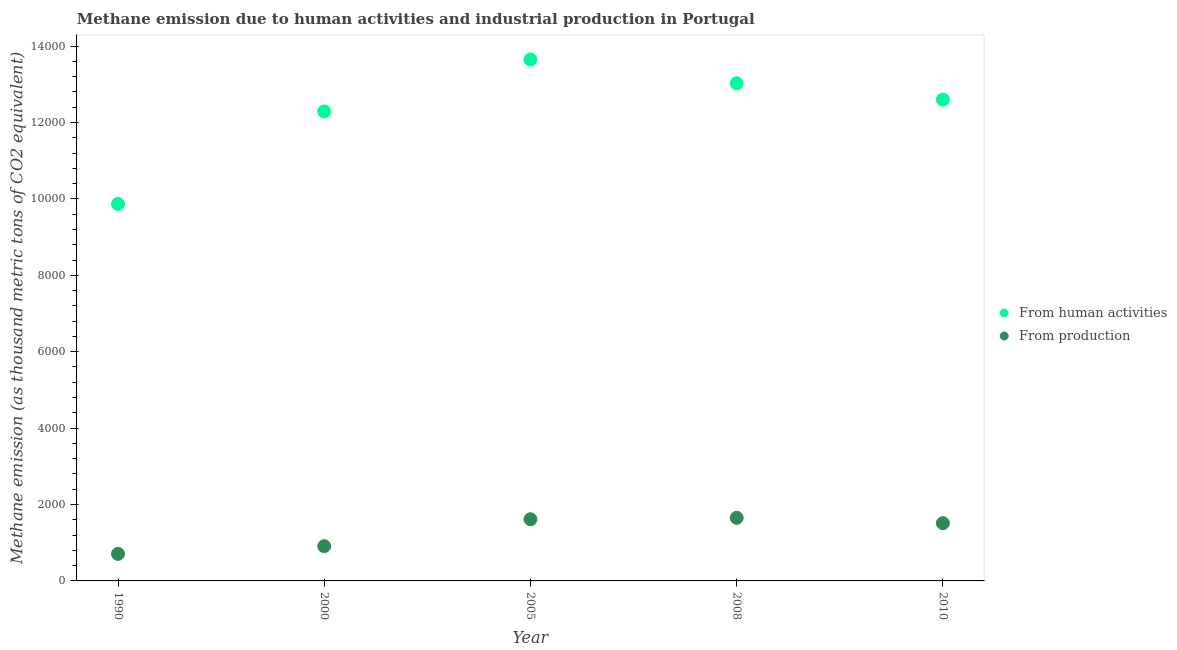Is the number of dotlines equal to the number of legend labels?
Your response must be concise. Yes. What is the amount of emissions from human activities in 2010?
Provide a succinct answer. 1.26e+04. Across all years, what is the maximum amount of emissions generated from industries?
Keep it short and to the point. 1651.1. Across all years, what is the minimum amount of emissions from human activities?
Your response must be concise. 9868.6. In which year was the amount of emissions generated from industries minimum?
Give a very brief answer. 1990. What is the total amount of emissions from human activities in the graph?
Provide a succinct answer. 6.14e+04. What is the difference between the amount of emissions generated from industries in 1990 and that in 2010?
Make the answer very short. -802.8. What is the difference between the amount of emissions from human activities in 2010 and the amount of emissions generated from industries in 2005?
Offer a very short reply. 1.10e+04. What is the average amount of emissions generated from industries per year?
Provide a succinct answer. 1279.18. In the year 1990, what is the difference between the amount of emissions from human activities and amount of emissions generated from industries?
Offer a very short reply. 9159.9. What is the ratio of the amount of emissions generated from industries in 2000 to that in 2010?
Provide a short and direct response. 0.6. Is the amount of emissions from human activities in 2008 less than that in 2010?
Give a very brief answer. No. Is the difference between the amount of emissions from human activities in 2000 and 2005 greater than the difference between the amount of emissions generated from industries in 2000 and 2005?
Keep it short and to the point. No. What is the difference between the highest and the second highest amount of emissions from human activities?
Ensure brevity in your answer.  620. What is the difference between the highest and the lowest amount of emissions from human activities?
Your answer should be compact. 3778.3. In how many years, is the amount of emissions from human activities greater than the average amount of emissions from human activities taken over all years?
Make the answer very short. 4. What is the difference between two consecutive major ticks on the Y-axis?
Give a very brief answer. 2000. Are the values on the major ticks of Y-axis written in scientific E-notation?
Give a very brief answer. No. Does the graph contain any zero values?
Your response must be concise. No. Does the graph contain grids?
Offer a very short reply. No. Where does the legend appear in the graph?
Your answer should be very brief. Center right. How many legend labels are there?
Your answer should be very brief. 2. What is the title of the graph?
Provide a short and direct response. Methane emission due to human activities and industrial production in Portugal. Does "National Tourists" appear as one of the legend labels in the graph?
Offer a very short reply. No. What is the label or title of the Y-axis?
Your answer should be very brief. Methane emission (as thousand metric tons of CO2 equivalent). What is the Methane emission (as thousand metric tons of CO2 equivalent) of From human activities in 1990?
Offer a terse response. 9868.6. What is the Methane emission (as thousand metric tons of CO2 equivalent) in From production in 1990?
Your answer should be very brief. 708.7. What is the Methane emission (as thousand metric tons of CO2 equivalent) of From human activities in 2000?
Your response must be concise. 1.23e+04. What is the Methane emission (as thousand metric tons of CO2 equivalent) in From production in 2000?
Give a very brief answer. 909.6. What is the Methane emission (as thousand metric tons of CO2 equivalent) in From human activities in 2005?
Provide a succinct answer. 1.36e+04. What is the Methane emission (as thousand metric tons of CO2 equivalent) in From production in 2005?
Offer a very short reply. 1615. What is the Methane emission (as thousand metric tons of CO2 equivalent) of From human activities in 2008?
Keep it short and to the point. 1.30e+04. What is the Methane emission (as thousand metric tons of CO2 equivalent) in From production in 2008?
Keep it short and to the point. 1651.1. What is the Methane emission (as thousand metric tons of CO2 equivalent) of From human activities in 2010?
Make the answer very short. 1.26e+04. What is the Methane emission (as thousand metric tons of CO2 equivalent) in From production in 2010?
Provide a short and direct response. 1511.5. Across all years, what is the maximum Methane emission (as thousand metric tons of CO2 equivalent) in From human activities?
Your response must be concise. 1.36e+04. Across all years, what is the maximum Methane emission (as thousand metric tons of CO2 equivalent) of From production?
Provide a succinct answer. 1651.1. Across all years, what is the minimum Methane emission (as thousand metric tons of CO2 equivalent) in From human activities?
Make the answer very short. 9868.6. Across all years, what is the minimum Methane emission (as thousand metric tons of CO2 equivalent) of From production?
Your answer should be compact. 708.7. What is the total Methane emission (as thousand metric tons of CO2 equivalent) in From human activities in the graph?
Provide a succinct answer. 6.14e+04. What is the total Methane emission (as thousand metric tons of CO2 equivalent) of From production in the graph?
Offer a terse response. 6395.9. What is the difference between the Methane emission (as thousand metric tons of CO2 equivalent) of From human activities in 1990 and that in 2000?
Provide a short and direct response. -2420.5. What is the difference between the Methane emission (as thousand metric tons of CO2 equivalent) of From production in 1990 and that in 2000?
Your answer should be very brief. -200.9. What is the difference between the Methane emission (as thousand metric tons of CO2 equivalent) in From human activities in 1990 and that in 2005?
Your answer should be very brief. -3778.3. What is the difference between the Methane emission (as thousand metric tons of CO2 equivalent) in From production in 1990 and that in 2005?
Your answer should be very brief. -906.3. What is the difference between the Methane emission (as thousand metric tons of CO2 equivalent) in From human activities in 1990 and that in 2008?
Your response must be concise. -3158.3. What is the difference between the Methane emission (as thousand metric tons of CO2 equivalent) in From production in 1990 and that in 2008?
Your answer should be very brief. -942.4. What is the difference between the Methane emission (as thousand metric tons of CO2 equivalent) of From human activities in 1990 and that in 2010?
Your response must be concise. -2731.9. What is the difference between the Methane emission (as thousand metric tons of CO2 equivalent) of From production in 1990 and that in 2010?
Your response must be concise. -802.8. What is the difference between the Methane emission (as thousand metric tons of CO2 equivalent) in From human activities in 2000 and that in 2005?
Offer a very short reply. -1357.8. What is the difference between the Methane emission (as thousand metric tons of CO2 equivalent) in From production in 2000 and that in 2005?
Keep it short and to the point. -705.4. What is the difference between the Methane emission (as thousand metric tons of CO2 equivalent) of From human activities in 2000 and that in 2008?
Keep it short and to the point. -737.8. What is the difference between the Methane emission (as thousand metric tons of CO2 equivalent) of From production in 2000 and that in 2008?
Make the answer very short. -741.5. What is the difference between the Methane emission (as thousand metric tons of CO2 equivalent) in From human activities in 2000 and that in 2010?
Ensure brevity in your answer.  -311.4. What is the difference between the Methane emission (as thousand metric tons of CO2 equivalent) in From production in 2000 and that in 2010?
Offer a very short reply. -601.9. What is the difference between the Methane emission (as thousand metric tons of CO2 equivalent) of From human activities in 2005 and that in 2008?
Your answer should be compact. 620. What is the difference between the Methane emission (as thousand metric tons of CO2 equivalent) in From production in 2005 and that in 2008?
Ensure brevity in your answer.  -36.1. What is the difference between the Methane emission (as thousand metric tons of CO2 equivalent) of From human activities in 2005 and that in 2010?
Make the answer very short. 1046.4. What is the difference between the Methane emission (as thousand metric tons of CO2 equivalent) in From production in 2005 and that in 2010?
Ensure brevity in your answer.  103.5. What is the difference between the Methane emission (as thousand metric tons of CO2 equivalent) in From human activities in 2008 and that in 2010?
Your answer should be very brief. 426.4. What is the difference between the Methane emission (as thousand metric tons of CO2 equivalent) of From production in 2008 and that in 2010?
Ensure brevity in your answer.  139.6. What is the difference between the Methane emission (as thousand metric tons of CO2 equivalent) in From human activities in 1990 and the Methane emission (as thousand metric tons of CO2 equivalent) in From production in 2000?
Ensure brevity in your answer.  8959. What is the difference between the Methane emission (as thousand metric tons of CO2 equivalent) in From human activities in 1990 and the Methane emission (as thousand metric tons of CO2 equivalent) in From production in 2005?
Your response must be concise. 8253.6. What is the difference between the Methane emission (as thousand metric tons of CO2 equivalent) of From human activities in 1990 and the Methane emission (as thousand metric tons of CO2 equivalent) of From production in 2008?
Give a very brief answer. 8217.5. What is the difference between the Methane emission (as thousand metric tons of CO2 equivalent) of From human activities in 1990 and the Methane emission (as thousand metric tons of CO2 equivalent) of From production in 2010?
Offer a very short reply. 8357.1. What is the difference between the Methane emission (as thousand metric tons of CO2 equivalent) of From human activities in 2000 and the Methane emission (as thousand metric tons of CO2 equivalent) of From production in 2005?
Make the answer very short. 1.07e+04. What is the difference between the Methane emission (as thousand metric tons of CO2 equivalent) of From human activities in 2000 and the Methane emission (as thousand metric tons of CO2 equivalent) of From production in 2008?
Give a very brief answer. 1.06e+04. What is the difference between the Methane emission (as thousand metric tons of CO2 equivalent) of From human activities in 2000 and the Methane emission (as thousand metric tons of CO2 equivalent) of From production in 2010?
Give a very brief answer. 1.08e+04. What is the difference between the Methane emission (as thousand metric tons of CO2 equivalent) in From human activities in 2005 and the Methane emission (as thousand metric tons of CO2 equivalent) in From production in 2008?
Make the answer very short. 1.20e+04. What is the difference between the Methane emission (as thousand metric tons of CO2 equivalent) in From human activities in 2005 and the Methane emission (as thousand metric tons of CO2 equivalent) in From production in 2010?
Your answer should be compact. 1.21e+04. What is the difference between the Methane emission (as thousand metric tons of CO2 equivalent) in From human activities in 2008 and the Methane emission (as thousand metric tons of CO2 equivalent) in From production in 2010?
Provide a succinct answer. 1.15e+04. What is the average Methane emission (as thousand metric tons of CO2 equivalent) of From human activities per year?
Provide a succinct answer. 1.23e+04. What is the average Methane emission (as thousand metric tons of CO2 equivalent) in From production per year?
Ensure brevity in your answer.  1279.18. In the year 1990, what is the difference between the Methane emission (as thousand metric tons of CO2 equivalent) in From human activities and Methane emission (as thousand metric tons of CO2 equivalent) in From production?
Your answer should be very brief. 9159.9. In the year 2000, what is the difference between the Methane emission (as thousand metric tons of CO2 equivalent) in From human activities and Methane emission (as thousand metric tons of CO2 equivalent) in From production?
Ensure brevity in your answer.  1.14e+04. In the year 2005, what is the difference between the Methane emission (as thousand metric tons of CO2 equivalent) in From human activities and Methane emission (as thousand metric tons of CO2 equivalent) in From production?
Provide a short and direct response. 1.20e+04. In the year 2008, what is the difference between the Methane emission (as thousand metric tons of CO2 equivalent) in From human activities and Methane emission (as thousand metric tons of CO2 equivalent) in From production?
Your answer should be compact. 1.14e+04. In the year 2010, what is the difference between the Methane emission (as thousand metric tons of CO2 equivalent) of From human activities and Methane emission (as thousand metric tons of CO2 equivalent) of From production?
Keep it short and to the point. 1.11e+04. What is the ratio of the Methane emission (as thousand metric tons of CO2 equivalent) of From human activities in 1990 to that in 2000?
Provide a short and direct response. 0.8. What is the ratio of the Methane emission (as thousand metric tons of CO2 equivalent) in From production in 1990 to that in 2000?
Offer a terse response. 0.78. What is the ratio of the Methane emission (as thousand metric tons of CO2 equivalent) in From human activities in 1990 to that in 2005?
Offer a terse response. 0.72. What is the ratio of the Methane emission (as thousand metric tons of CO2 equivalent) in From production in 1990 to that in 2005?
Provide a succinct answer. 0.44. What is the ratio of the Methane emission (as thousand metric tons of CO2 equivalent) in From human activities in 1990 to that in 2008?
Your answer should be compact. 0.76. What is the ratio of the Methane emission (as thousand metric tons of CO2 equivalent) in From production in 1990 to that in 2008?
Keep it short and to the point. 0.43. What is the ratio of the Methane emission (as thousand metric tons of CO2 equivalent) of From human activities in 1990 to that in 2010?
Make the answer very short. 0.78. What is the ratio of the Methane emission (as thousand metric tons of CO2 equivalent) in From production in 1990 to that in 2010?
Provide a short and direct response. 0.47. What is the ratio of the Methane emission (as thousand metric tons of CO2 equivalent) of From human activities in 2000 to that in 2005?
Give a very brief answer. 0.9. What is the ratio of the Methane emission (as thousand metric tons of CO2 equivalent) of From production in 2000 to that in 2005?
Your answer should be very brief. 0.56. What is the ratio of the Methane emission (as thousand metric tons of CO2 equivalent) in From human activities in 2000 to that in 2008?
Provide a succinct answer. 0.94. What is the ratio of the Methane emission (as thousand metric tons of CO2 equivalent) in From production in 2000 to that in 2008?
Offer a terse response. 0.55. What is the ratio of the Methane emission (as thousand metric tons of CO2 equivalent) of From human activities in 2000 to that in 2010?
Offer a terse response. 0.98. What is the ratio of the Methane emission (as thousand metric tons of CO2 equivalent) in From production in 2000 to that in 2010?
Provide a succinct answer. 0.6. What is the ratio of the Methane emission (as thousand metric tons of CO2 equivalent) of From human activities in 2005 to that in 2008?
Provide a succinct answer. 1.05. What is the ratio of the Methane emission (as thousand metric tons of CO2 equivalent) in From production in 2005 to that in 2008?
Make the answer very short. 0.98. What is the ratio of the Methane emission (as thousand metric tons of CO2 equivalent) of From human activities in 2005 to that in 2010?
Provide a succinct answer. 1.08. What is the ratio of the Methane emission (as thousand metric tons of CO2 equivalent) of From production in 2005 to that in 2010?
Provide a short and direct response. 1.07. What is the ratio of the Methane emission (as thousand metric tons of CO2 equivalent) in From human activities in 2008 to that in 2010?
Offer a terse response. 1.03. What is the ratio of the Methane emission (as thousand metric tons of CO2 equivalent) of From production in 2008 to that in 2010?
Keep it short and to the point. 1.09. What is the difference between the highest and the second highest Methane emission (as thousand metric tons of CO2 equivalent) in From human activities?
Your answer should be very brief. 620. What is the difference between the highest and the second highest Methane emission (as thousand metric tons of CO2 equivalent) in From production?
Your answer should be compact. 36.1. What is the difference between the highest and the lowest Methane emission (as thousand metric tons of CO2 equivalent) in From human activities?
Ensure brevity in your answer.  3778.3. What is the difference between the highest and the lowest Methane emission (as thousand metric tons of CO2 equivalent) of From production?
Make the answer very short. 942.4. 